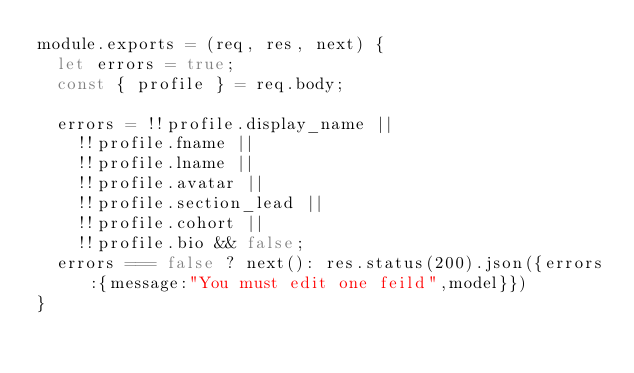<code> <loc_0><loc_0><loc_500><loc_500><_JavaScript_>module.exports = (req, res, next) {
  let errors = true;
  const { profile } = req.body;

  errors = !!profile.display_name ||
    !!profile.fname ||
    !!profile.lname ||
    !!profile.avatar ||
    !!profile.section_lead ||
    !!profile.cohort ||
    !!profile.bio && false;
  errors === false ? next(): res.status(200).json({errors:{message:"You must edit one feild",model}})
}
</code> 